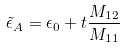Convert formula to latex. <formula><loc_0><loc_0><loc_500><loc_500>\tilde { \epsilon } _ { A } = \epsilon _ { 0 } + t \frac { M _ { 1 2 } } { M _ { 1 1 } }</formula> 